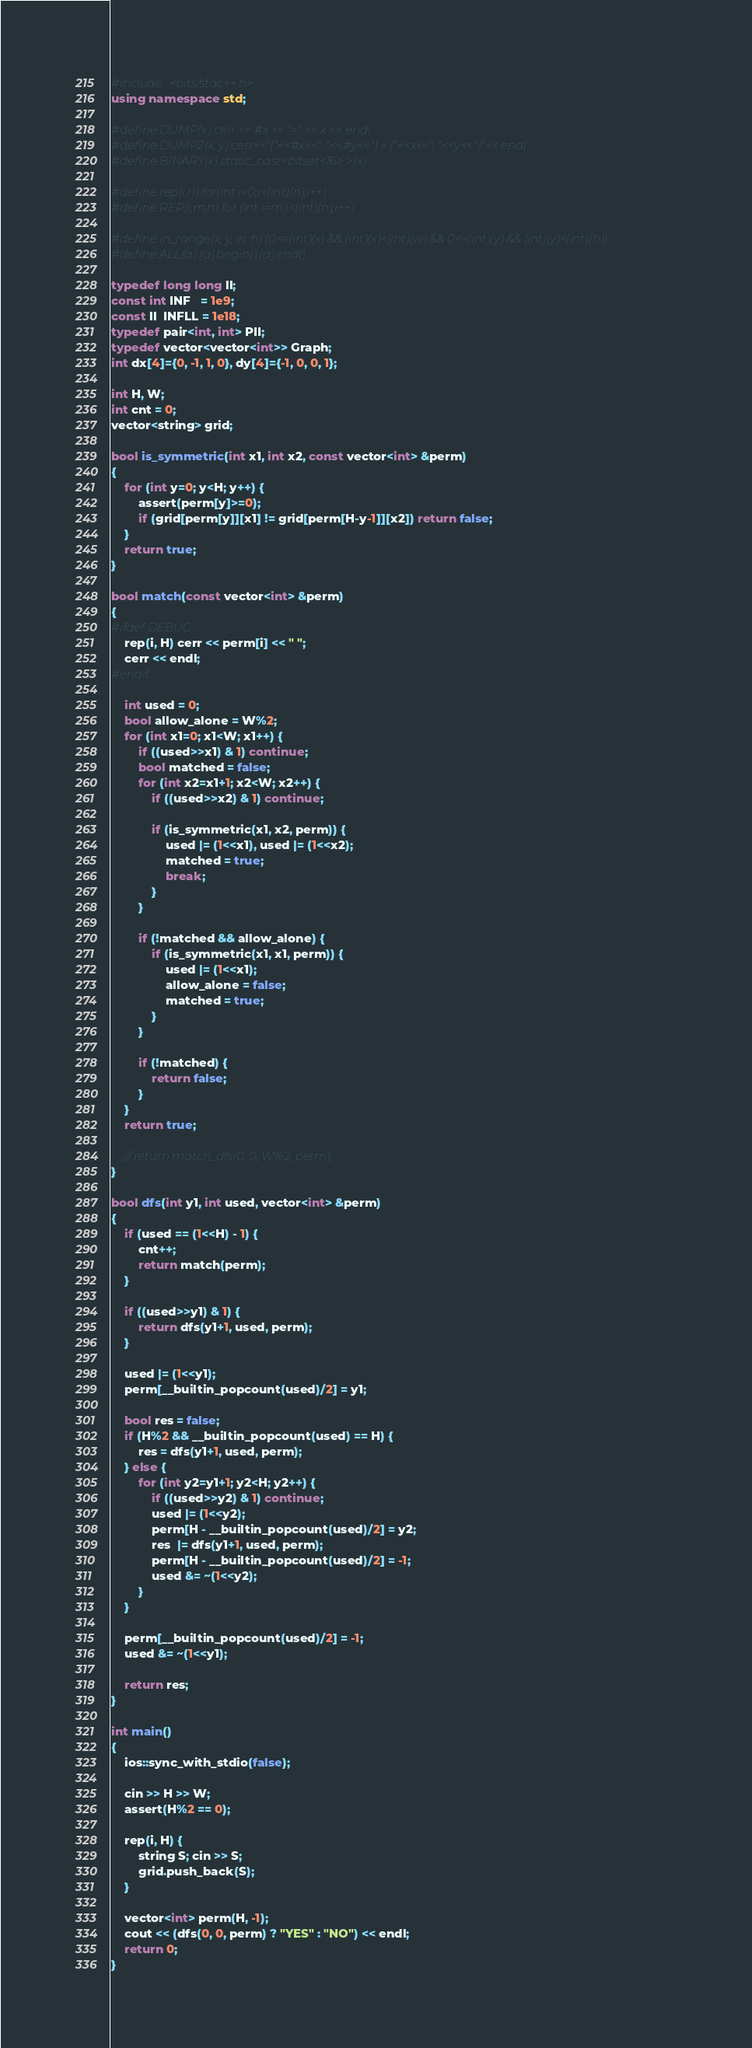Convert code to text. <code><loc_0><loc_0><loc_500><loc_500><_C++_>#include <bits/stdc++.h>
using namespace std;

#define DUMP(x) cerr << #x << "=" << x << endl
#define DUMP2(x, y) cerr<<"("<<#x<<", "<<#y<<") = ("<<x<<", "<<y<<")"<< endl
#define BINARY(x) static_cast<bitset<16> >(x)

#define rep(i,n) for(int i=0;i<(int)(n);i++)
#define REP(i,m,n) for (int i=m;i<(int)(n);i++)

#define in_range(x, y, w, h) (0<=(int)(x) && (int)(x)<(int)(w) && 0<=(int)(y) && (int)(y)<(int)(h))
#define ALL(a) (a).begin(),(a).end()

typedef long long ll;
const int INF   = 1e9;
const ll  INFLL = 1e18;
typedef pair<int, int> PII;
typedef vector<vector<int>> Graph;
int dx[4]={0, -1, 1, 0}, dy[4]={-1, 0, 0, 1};

int H, W;
int cnt = 0;
vector<string> grid;

bool is_symmetric(int x1, int x2, const vector<int> &perm)
{
    for (int y=0; y<H; y++) {
        assert(perm[y]>=0);
        if (grid[perm[y]][x1] != grid[perm[H-y-1]][x2]) return false;
    }
    return true;
}

bool match(const vector<int> &perm)
{
#ifdef DEBUG
    rep(i, H) cerr << perm[i] << " ";
    cerr << endl;
#endif

    int used = 0;
    bool allow_alone = W%2;
    for (int x1=0; x1<W; x1++) {
        if ((used>>x1) & 1) continue;
        bool matched = false;
        for (int x2=x1+1; x2<W; x2++) {
            if ((used>>x2) & 1) continue;

            if (is_symmetric(x1, x2, perm)) {
                used |= (1<<x1), used |= (1<<x2);
                matched = true;
                break;
            }
        }

        if (!matched && allow_alone) {
            if (is_symmetric(x1, x1, perm)) {
                used |= (1<<x1);
                allow_alone = false;
                matched = true;
            }
        }

        if (!matched) {
            return false;
        }
    }
    return true;

    // return match_dfs(0, 0, W%2, perm);
}

bool dfs(int y1, int used, vector<int> &perm)
{
    if (used == (1<<H) - 1) {
        cnt++;
        return match(perm);
    }

    if ((used>>y1) & 1) {
        return dfs(y1+1, used, perm);
    }

    used |= (1<<y1);
    perm[__builtin_popcount(used)/2] = y1;

    bool res = false;
    if (H%2 && __builtin_popcount(used) == H) {
        res = dfs(y1+1, used, perm);
    } else {
        for (int y2=y1+1; y2<H; y2++) {
            if ((used>>y2) & 1) continue; 
            used |= (1<<y2);
            perm[H - __builtin_popcount(used)/2] = y2;
            res  |= dfs(y1+1, used, perm);
            perm[H - __builtin_popcount(used)/2] = -1;
            used &= ~(1<<y2);
        }
    }

    perm[__builtin_popcount(used)/2] = -1;
    used &= ~(1<<y1);

    return res;
}

int main()
{
    ios::sync_with_stdio(false);

    cin >> H >> W;
    assert(H%2 == 0);

    rep(i, H) {
        string S; cin >> S;
        grid.push_back(S);
    }

    vector<int> perm(H, -1);
    cout << (dfs(0, 0, perm) ? "YES" : "NO") << endl;
    return 0;
}

</code> 